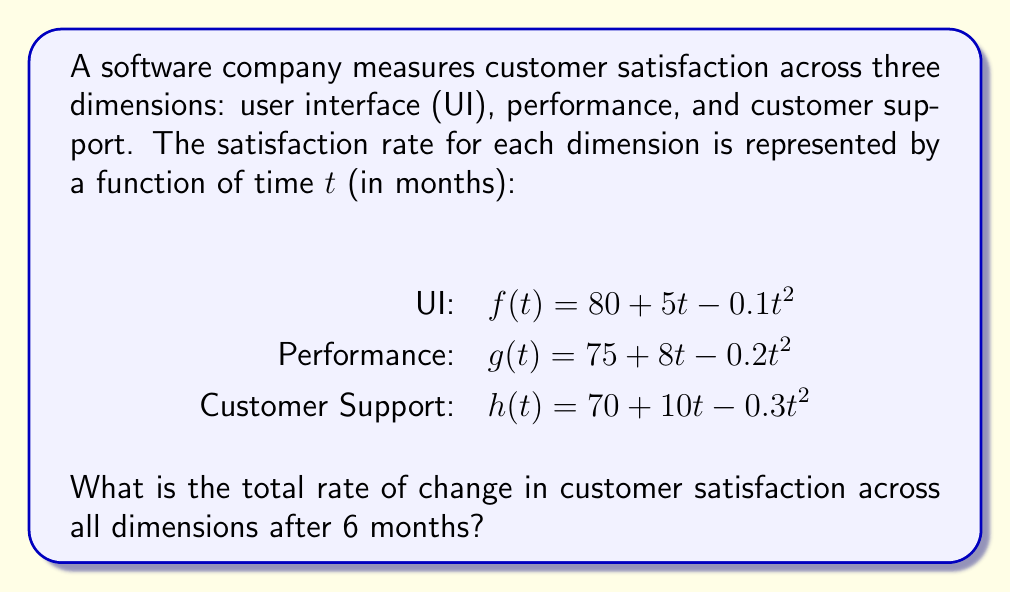Teach me how to tackle this problem. To solve this problem, we need to follow these steps:

1. Calculate the rate of change (derivative) for each dimension:
   
   UI: $\frac{df}{dt} = 5 - 0.2t$
   Performance: $\frac{dg}{dt} = 8 - 0.4t$
   Customer Support: $\frac{dh}{dt} = 10 - 0.6t$

2. Evaluate each rate of change at $t = 6$ months:
   
   UI: $\frac{df}{dt}(6) = 5 - 0.2(6) = 5 - 1.2 = 3.8$
   Performance: $\frac{dg}{dt}(6) = 8 - 0.4(6) = 8 - 2.4 = 5.6$
   Customer Support: $\frac{dh}{dt}(6) = 10 - 0.6(6) = 10 - 3.6 = 6.4$

3. Sum up the rates of change to get the total rate of change:

   Total rate of change = $3.8 + 5.6 + 6.4 = 15.8$

Therefore, the total rate of change in customer satisfaction across all dimensions after 6 months is 15.8 units per month.
Answer: 15.8 units per month 